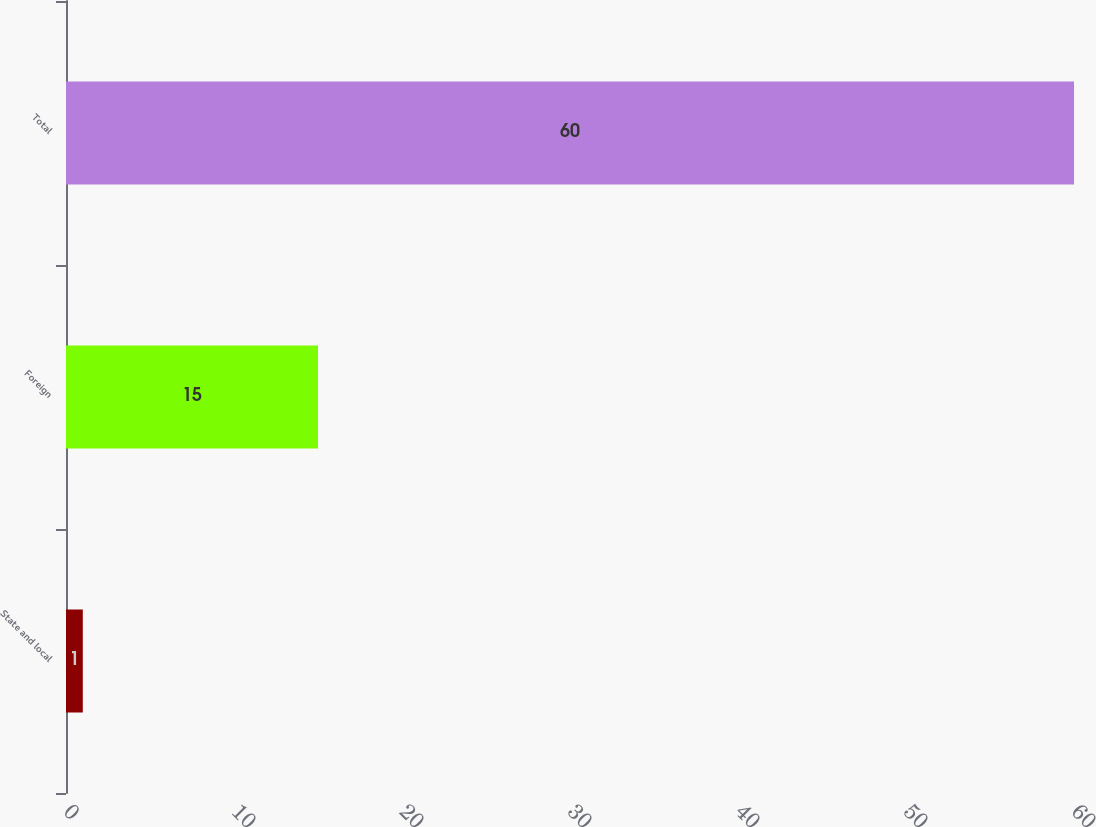<chart> <loc_0><loc_0><loc_500><loc_500><bar_chart><fcel>State and local<fcel>Foreign<fcel>Total<nl><fcel>1<fcel>15<fcel>60<nl></chart> 